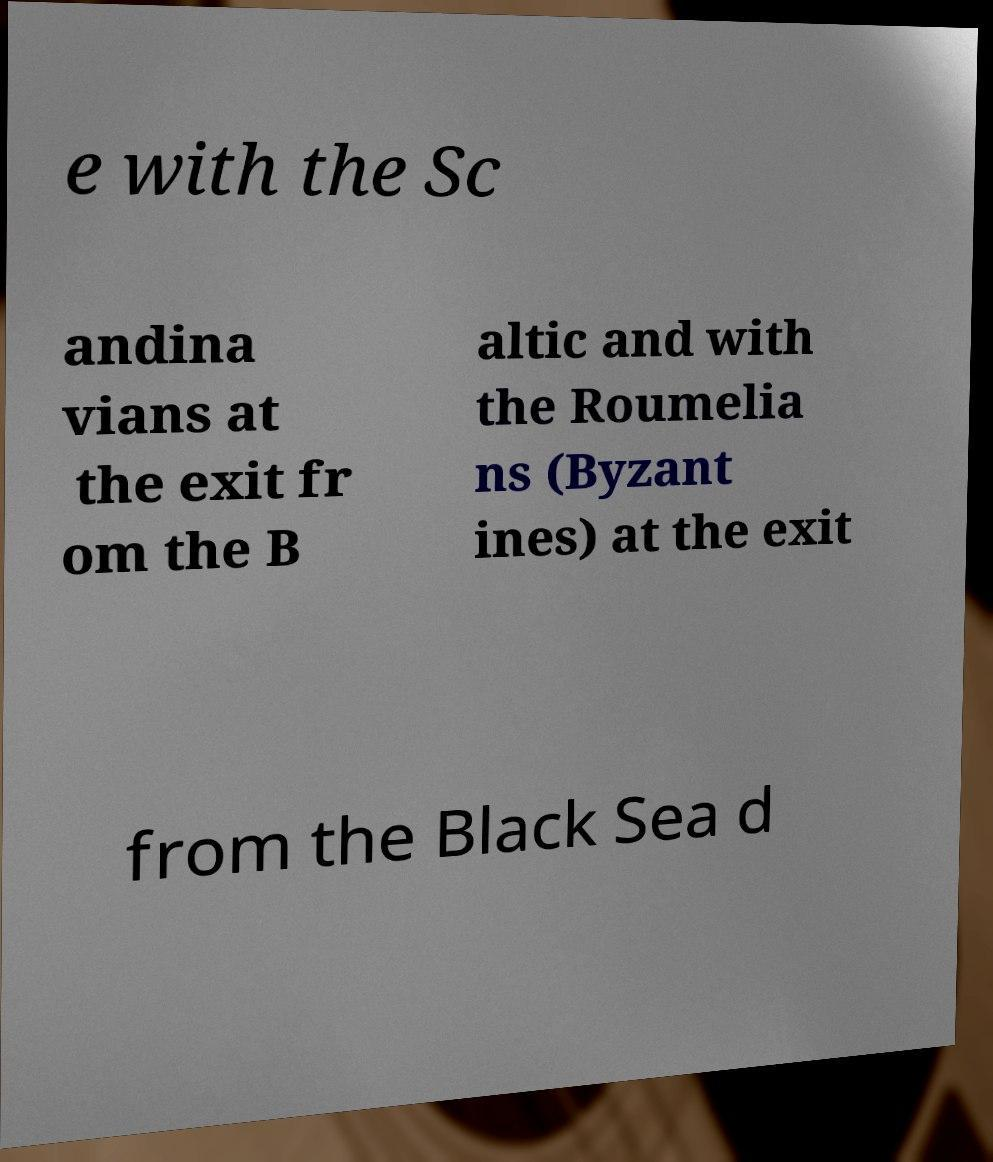Can you read and provide the text displayed in the image?This photo seems to have some interesting text. Can you extract and type it out for me? e with the Sc andina vians at the exit fr om the B altic and with the Roumelia ns (Byzant ines) at the exit from the Black Sea d 